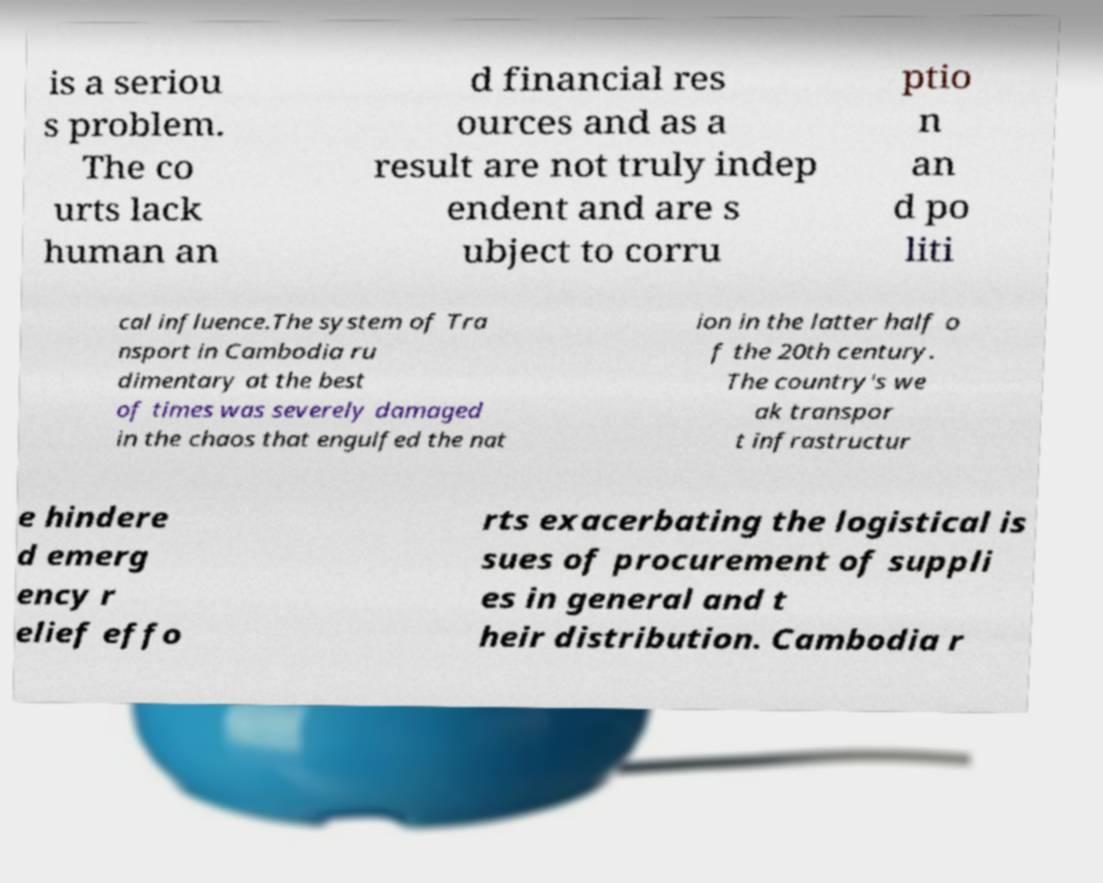What messages or text are displayed in this image? I need them in a readable, typed format. is a seriou s problem. The co urts lack human an d financial res ources and as a result are not truly indep endent and are s ubject to corru ptio n an d po liti cal influence.The system of Tra nsport in Cambodia ru dimentary at the best of times was severely damaged in the chaos that engulfed the nat ion in the latter half o f the 20th century. The country's we ak transpor t infrastructur e hindere d emerg ency r elief effo rts exacerbating the logistical is sues of procurement of suppli es in general and t heir distribution. Cambodia r 